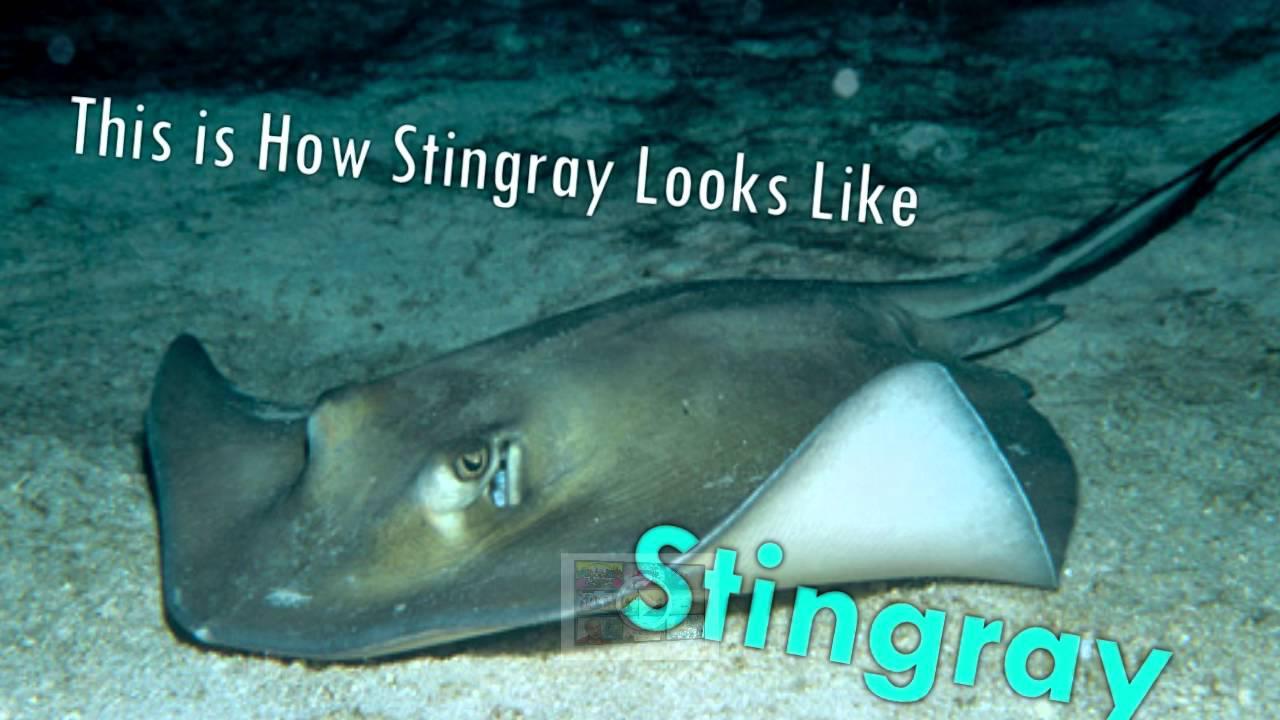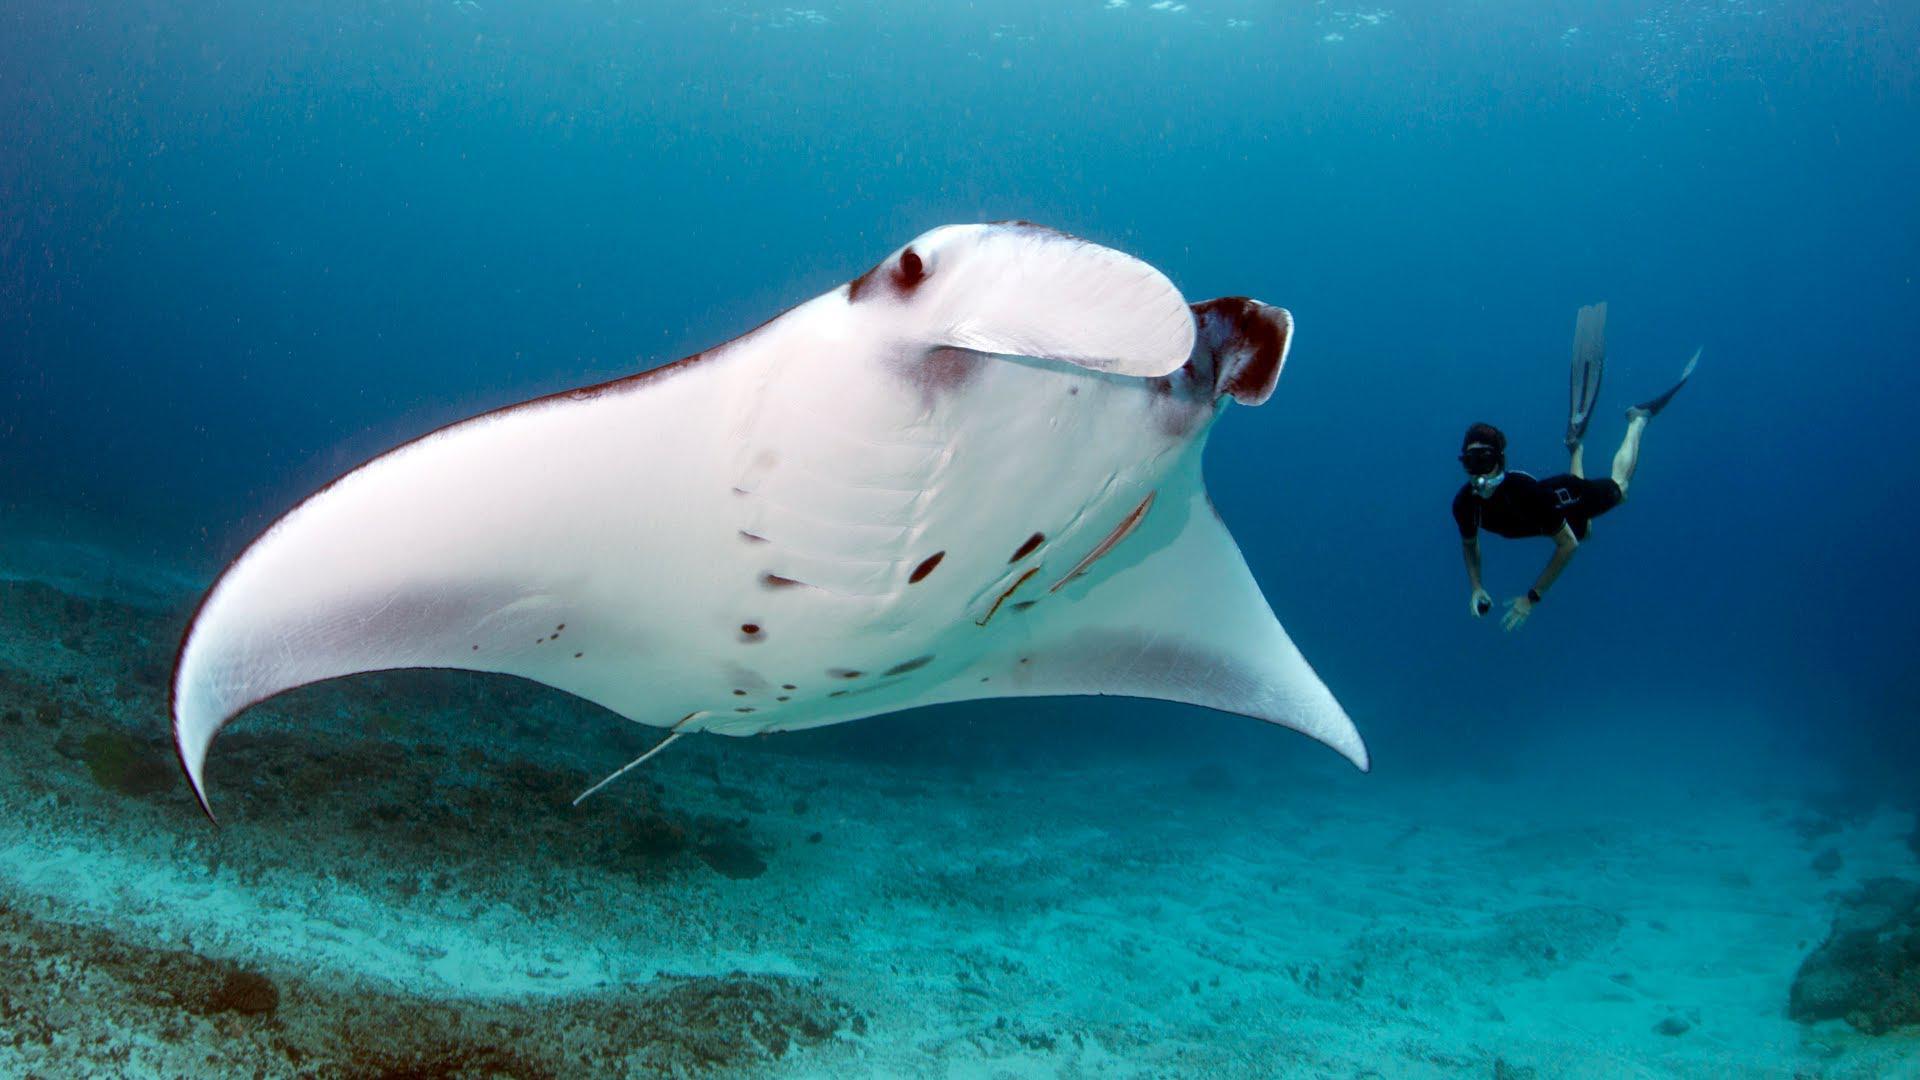The first image is the image on the left, the second image is the image on the right. Analyze the images presented: Is the assertion "There is a scuba diver on one of the images." valid? Answer yes or no. Yes. 